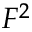<formula> <loc_0><loc_0><loc_500><loc_500>F ^ { 2 }</formula> 